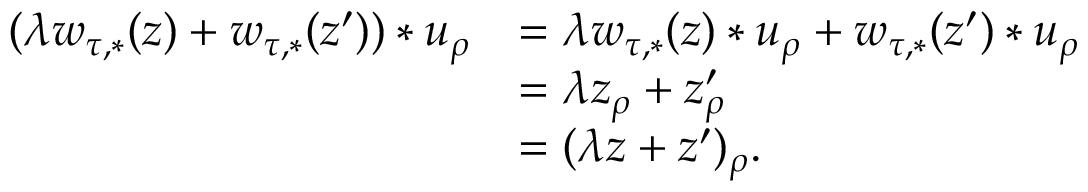<formula> <loc_0><loc_0><loc_500><loc_500>\begin{array} { r l } { ( \lambda w _ { \tau , * } ( z ) + w _ { \tau , * } ( z ^ { \prime } ) ) * u _ { \rho } } & { = \lambda w _ { \tau , * } ( z ) * u _ { \rho } + w _ { \tau , * } ( z ^ { \prime } ) * u _ { \rho } } \\ & { = \lambda z _ { \rho } + z _ { \rho } ^ { \prime } } \\ & { = ( \lambda z + z ^ { \prime } ) _ { \rho } . } \end{array}</formula> 